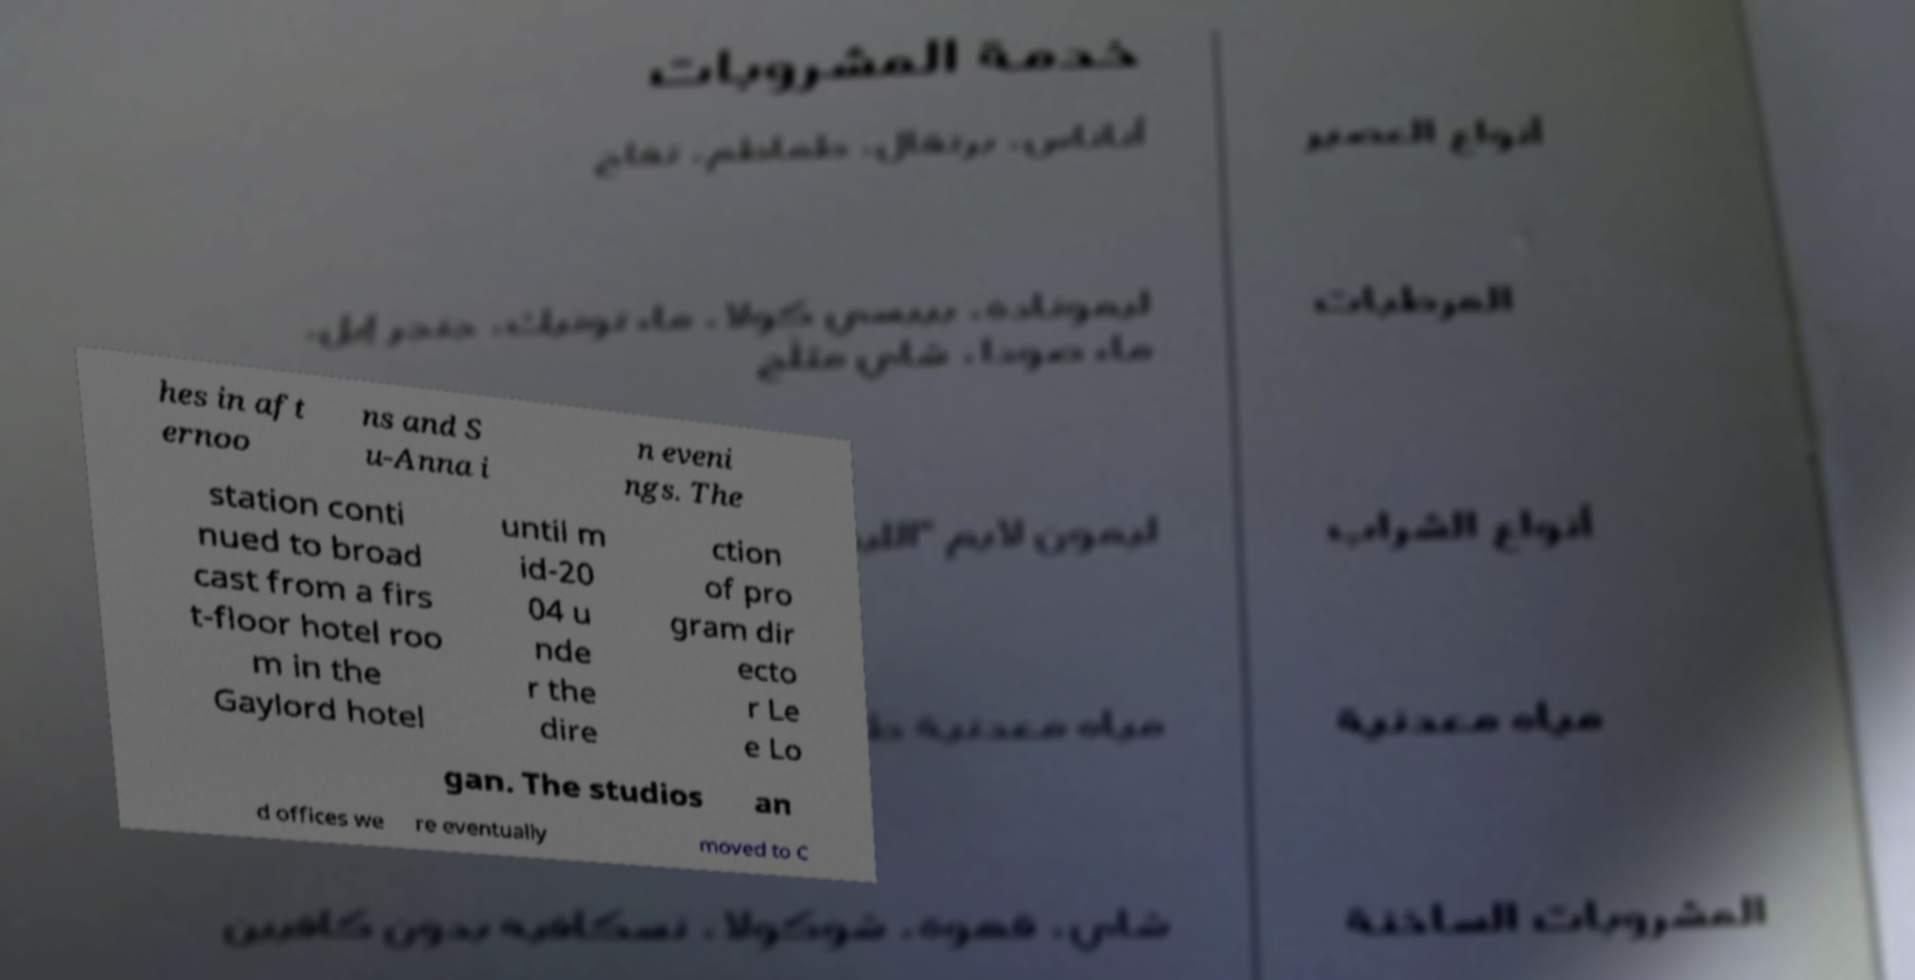Can you accurately transcribe the text from the provided image for me? hes in aft ernoo ns and S u-Anna i n eveni ngs. The station conti nued to broad cast from a firs t-floor hotel roo m in the Gaylord hotel until m id-20 04 u nde r the dire ction of pro gram dir ecto r Le e Lo gan. The studios an d offices we re eventually moved to C 